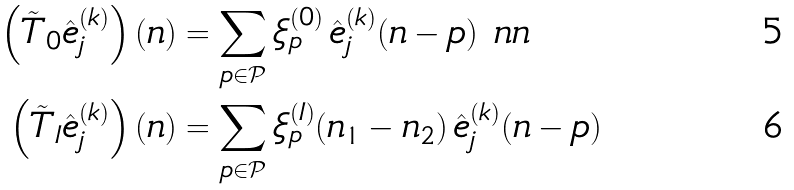<formula> <loc_0><loc_0><loc_500><loc_500>\left ( \tilde { T } _ { 0 } \hat { e } _ { j } ^ { ( k ) } \right ) ( n ) & = \sum _ { p \in \mathcal { P } } \xi ^ { ( 0 ) } _ { p } \, \hat { e } _ { j } ^ { ( k ) } ( n - p ) \ n n \\ \left ( \tilde { T } _ { I } \hat { e } _ { j } ^ { ( k ) } \right ) ( n ) & = \sum _ { p \in \mathcal { P } } \xi ^ { ( I ) } _ { p } ( n _ { 1 } - n _ { 2 } ) \, \hat { e } _ { j } ^ { ( k ) } ( n - p )</formula> 